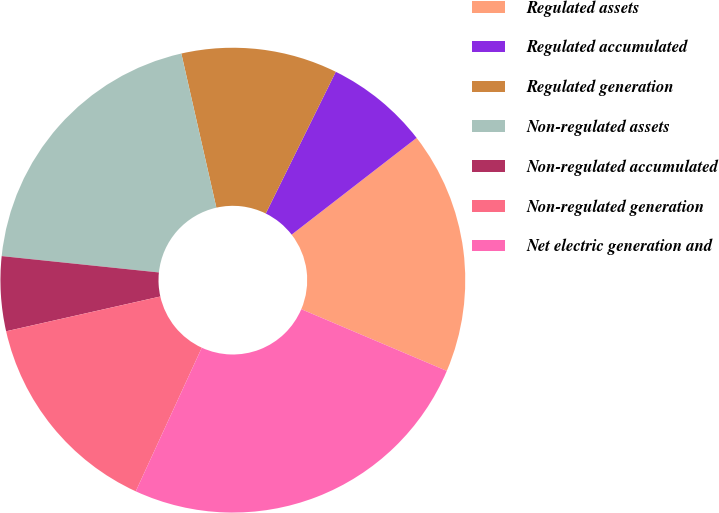<chart> <loc_0><loc_0><loc_500><loc_500><pie_chart><fcel>Regulated assets<fcel>Regulated accumulated<fcel>Regulated generation<fcel>Non-regulated assets<fcel>Non-regulated accumulated<fcel>Non-regulated generation<fcel>Net electric generation and<nl><fcel>16.87%<fcel>7.21%<fcel>10.86%<fcel>19.79%<fcel>5.18%<fcel>14.61%<fcel>25.47%<nl></chart> 